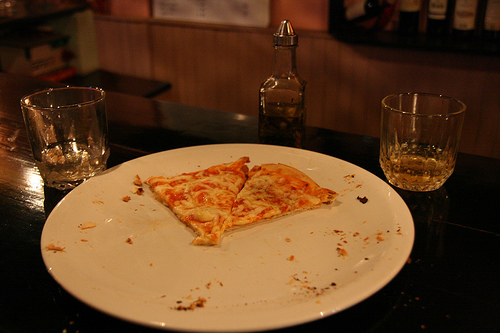Do you see pizzas or doughnuts that are not yellow? No, the pizza presented in the image has a predominantly yellow hue, typical of cheese melted on top. There are no doughnuts or other pizzas of different colors. 